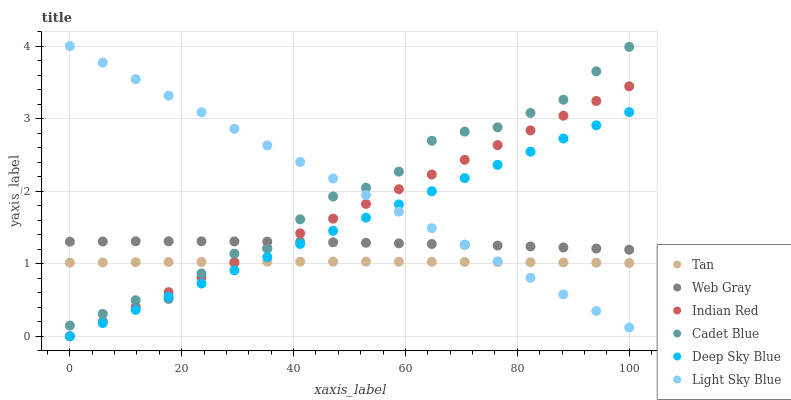Does Tan have the minimum area under the curve?
Answer yes or no. Yes. Does Light Sky Blue have the maximum area under the curve?
Answer yes or no. Yes. Does Indian Red have the minimum area under the curve?
Answer yes or no. No. Does Indian Red have the maximum area under the curve?
Answer yes or no. No. Is Deep Sky Blue the smoothest?
Answer yes or no. Yes. Is Cadet Blue the roughest?
Answer yes or no. Yes. Is Indian Red the smoothest?
Answer yes or no. No. Is Indian Red the roughest?
Answer yes or no. No. Does Indian Red have the lowest value?
Answer yes or no. Yes. Does Light Sky Blue have the lowest value?
Answer yes or no. No. Does Light Sky Blue have the highest value?
Answer yes or no. Yes. Does Indian Red have the highest value?
Answer yes or no. No. Is Tan less than Web Gray?
Answer yes or no. Yes. Is Web Gray greater than Tan?
Answer yes or no. Yes. Does Web Gray intersect Light Sky Blue?
Answer yes or no. Yes. Is Web Gray less than Light Sky Blue?
Answer yes or no. No. Is Web Gray greater than Light Sky Blue?
Answer yes or no. No. Does Tan intersect Web Gray?
Answer yes or no. No. 